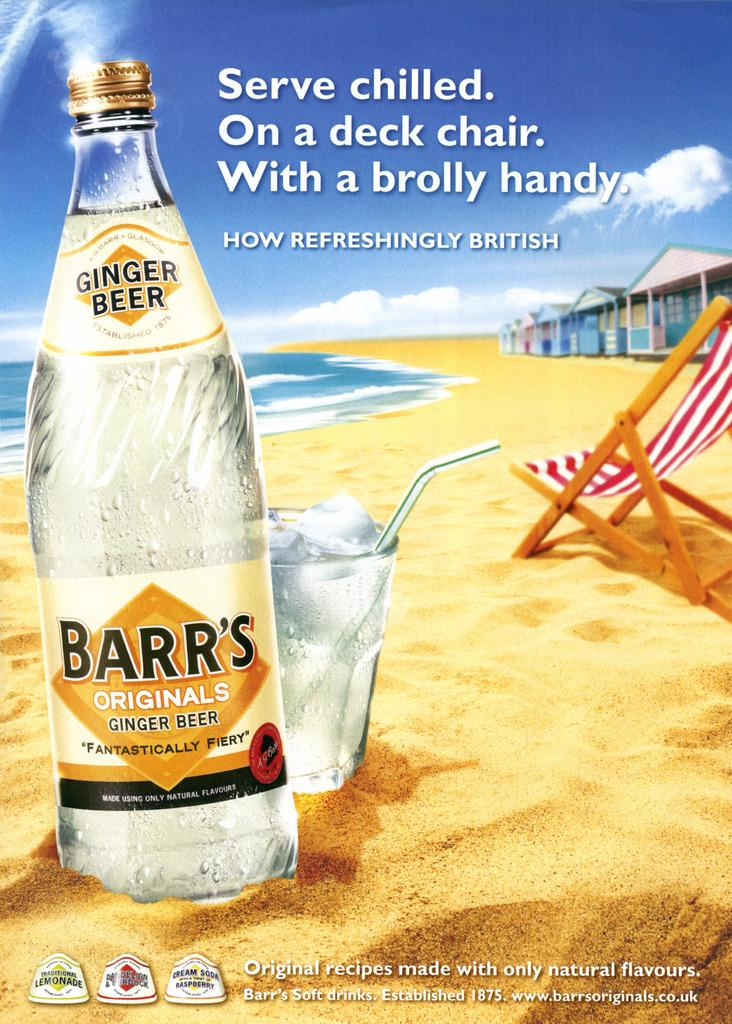<image>
Describe the image concisely. an advertisement about barrs original ginger beer being british 